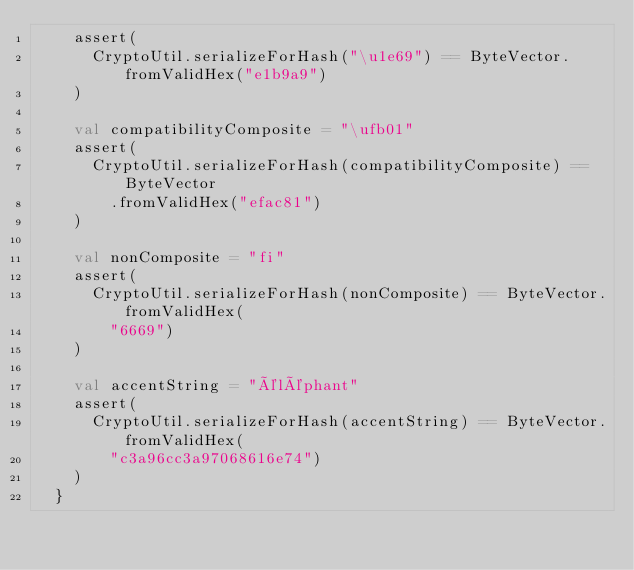Convert code to text. <code><loc_0><loc_0><loc_500><loc_500><_Scala_>    assert(
      CryptoUtil.serializeForHash("\u1e69") == ByteVector.fromValidHex("e1b9a9")
    )

    val compatibilityComposite = "\ufb01"
    assert(
      CryptoUtil.serializeForHash(compatibilityComposite) == ByteVector
        .fromValidHex("efac81")
    )

    val nonComposite = "fi"
    assert(
      CryptoUtil.serializeForHash(nonComposite) == ByteVector.fromValidHex(
        "6669")
    )

    val accentString = "éléphant"
    assert(
      CryptoUtil.serializeForHash(accentString) == ByteVector.fromValidHex(
        "c3a96cc3a97068616e74")
    )
  }
</code> 